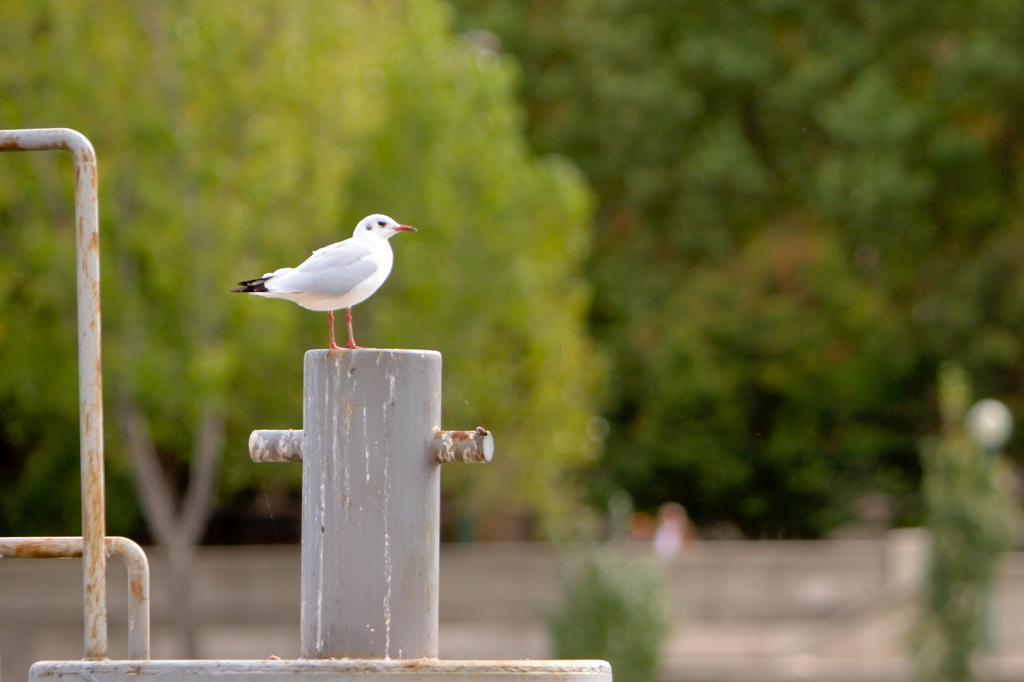In one or two sentences, can you explain what this image depicts? In the image we can see a bird, white in colour and the bird is sitting on a metal object. Here we can see the trees and the background is blurred. 